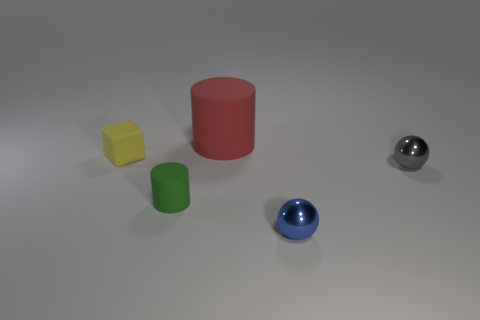There is a tiny rubber object that is in front of the small gray shiny ball; does it have the same shape as the small matte object that is left of the green matte cylinder?
Provide a succinct answer. No. Are there any other things that have the same shape as the tiny yellow object?
Provide a succinct answer. No. How many cylinders are either metallic things or red matte things?
Give a very brief answer. 1. What color is the tiny metallic sphere to the right of the blue ball?
Ensure brevity in your answer.  Gray. What is the shape of the green object that is the same size as the yellow object?
Your answer should be very brief. Cylinder. There is a big red matte cylinder; how many green cylinders are to the right of it?
Your response must be concise. 0. What number of objects are small brown shiny things or small metallic objects?
Provide a succinct answer. 2. There is a tiny object that is to the left of the red thing and on the right side of the rubber cube; what shape is it?
Provide a short and direct response. Cylinder. What number of small yellow matte blocks are there?
Your answer should be very brief. 1. There is a tiny ball that is made of the same material as the tiny blue object; what color is it?
Provide a short and direct response. Gray. 